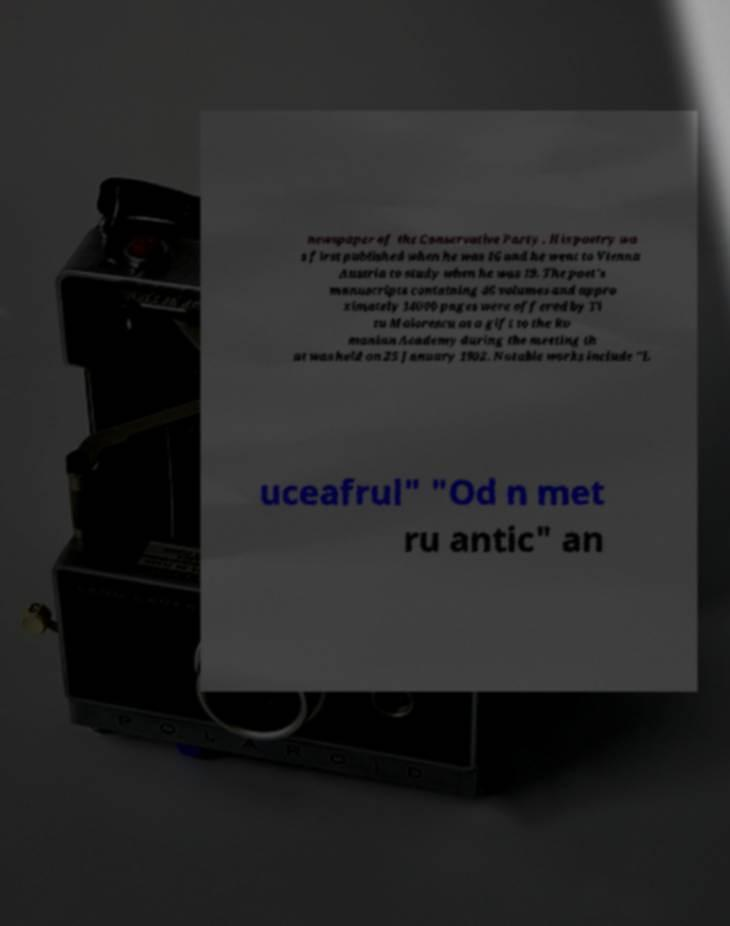Could you assist in decoding the text presented in this image and type it out clearly? newspaper of the Conservative Party . His poetry wa s first published when he was 16 and he went to Vienna Austria to study when he was 19. The poet's manuscripts containing 46 volumes and appro ximately 14000 pages were offered by Ti tu Maiorescu as a gift to the Ro manian Academy during the meeting th at was held on 25 January 1902. Notable works include "L uceafrul" "Od n met ru antic" an 